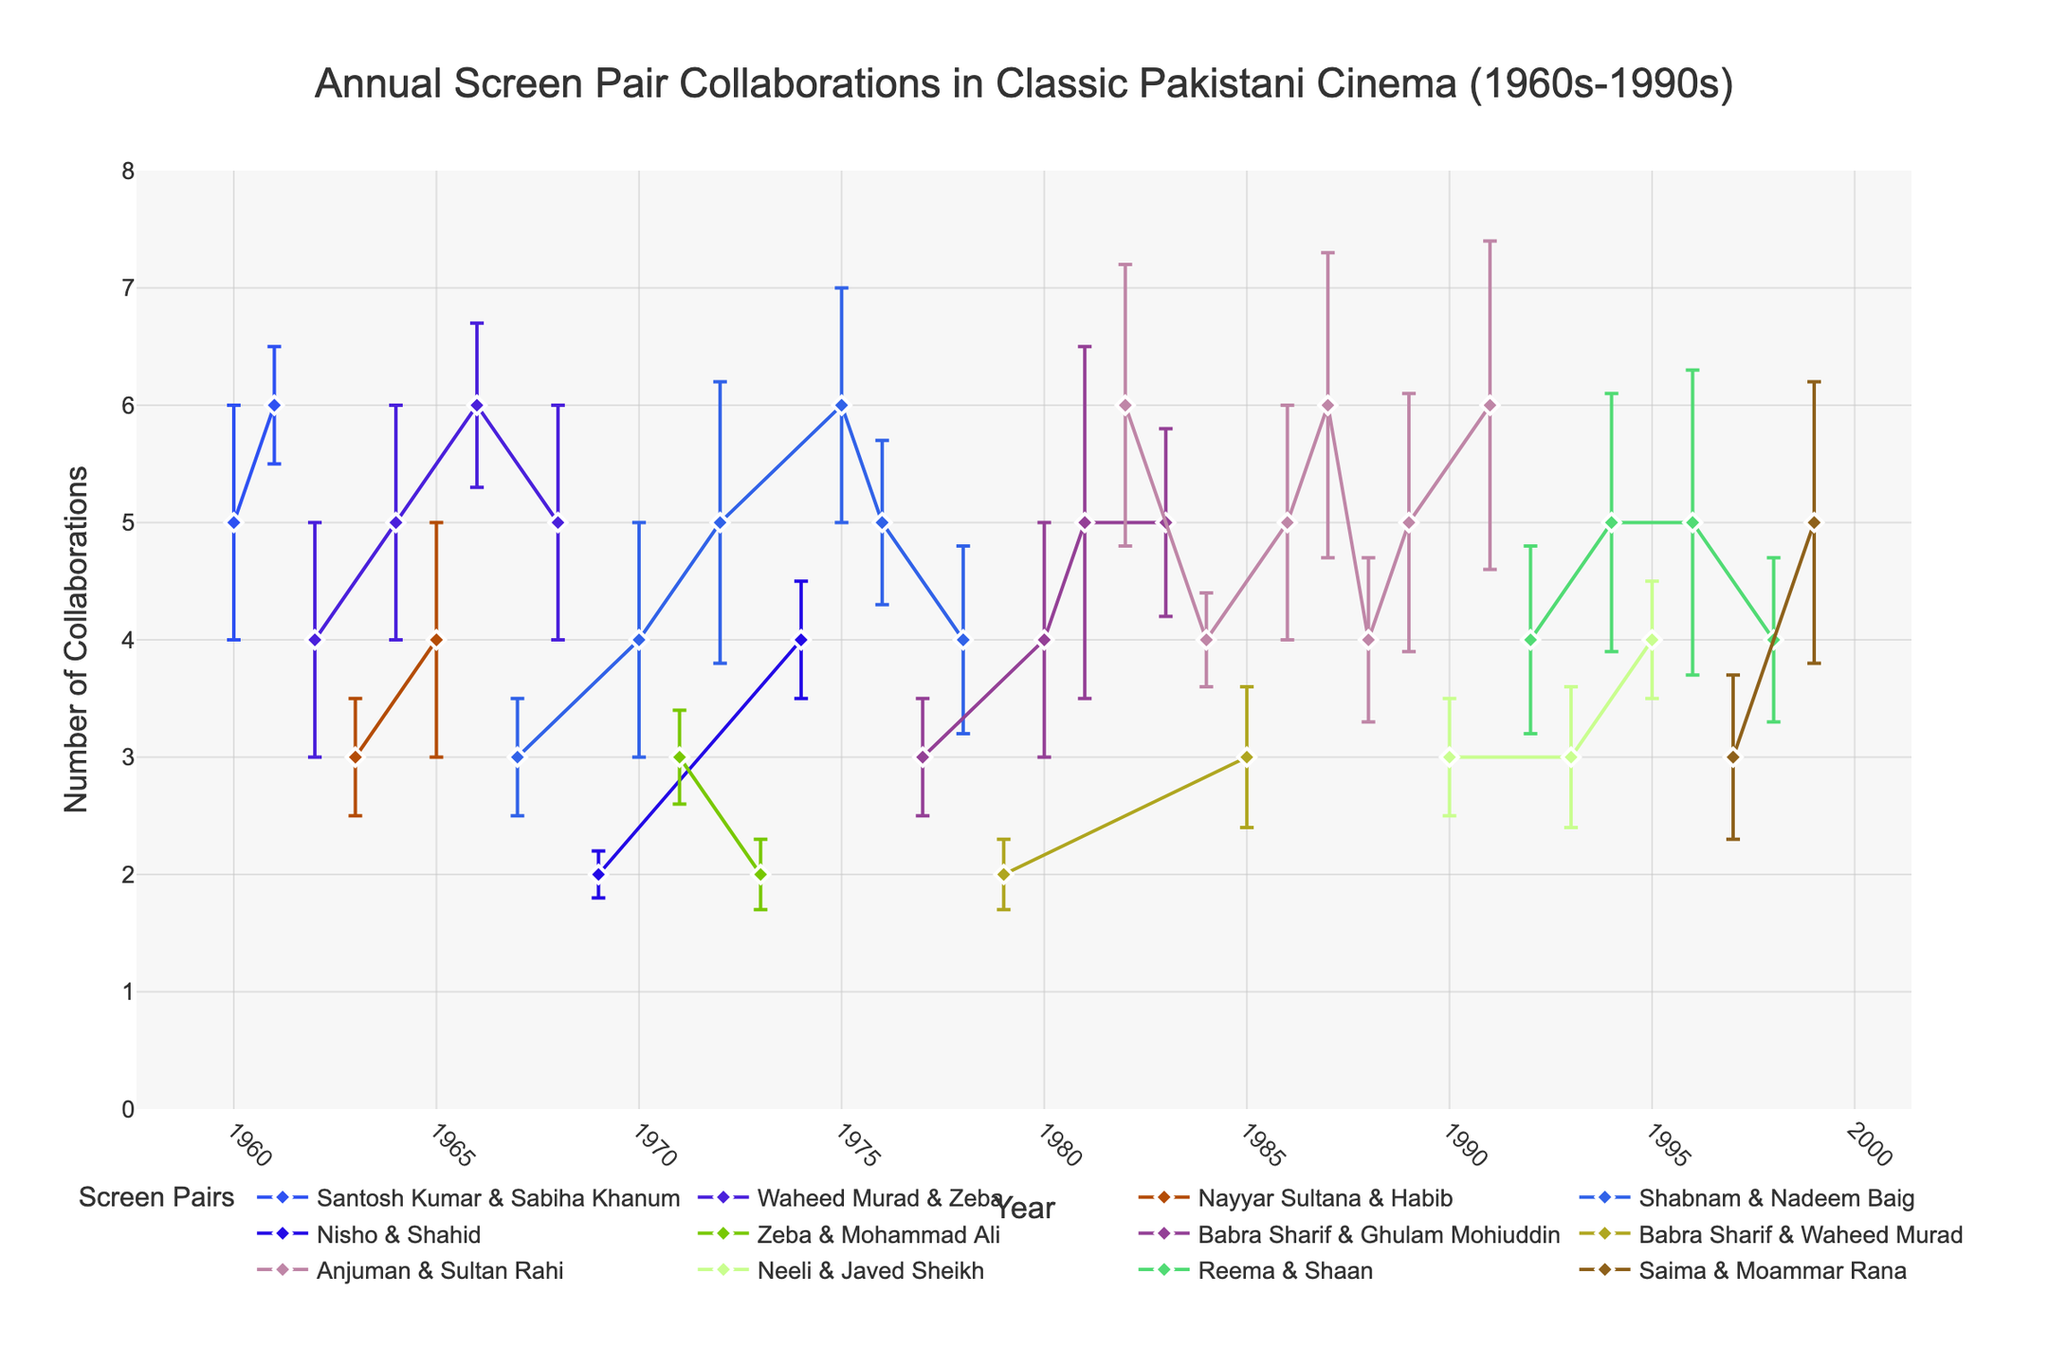How many collaborations did Shabnam & Nadeem Baig have in 1970? Look for the data point for Shabnam & Nadeem Baig in the year 1970. The y-axis value associated with that point is the number of collaborations.
Answer: 4 Which screen pair had the highest number of collaborations in 1982, and how many were there? Find the data points for the year 1982 and identify the screen pair with the highest y-axis value.
Answer: Anjuman & Sultan Rahi, 6 What is the average number of collaborations for Waheed Murad & Zeba between 1962 and 1968? List the number of collaborations for Waheed Murad & Zeba in the years 1962, 1964, 1966, and 1968. Then, sum those values and divide by the number of data points.
Answer: 5 In which year did Babra Sharif & Ghulam Mohiuddin have the least number of collaborations, and what was the number? Look at the data points for Babra Sharif & Ghulam Mohiuddin and find the year with the smallest y-axis value.
Answer: 1977, 3 How many total collaborations did Anjuman & Sultan Rahi have from 1982 to 1989? Sum the number of collaborations for Anjuman & Sultan Rahi for the years 1982, 1984, 1986, 1987, and 1989.
Answer: 26 Which screen pair showed the largest error bar in their collaborative frequency, and in which year did it occur? Identify the longest error bar (y-axis deviation) and note the screen pair and year associated with that bar.
Answer: Babra Sharif & Ghulam Mohiuddin, 1981 What is the trend in collaborations for Reema & Shaan from 1992 to 1998? Observe the data points for Reema & Shaan for the years 1992, 1994, 1996, and 1998. Describe whether the number of collaborations is increasing, decreasing, or stable over these years.
Answer: Alternating Which pair had more collaborations in their peak collaboration year: Shabnam & Nadeem Baig or Anjuman & Sultan Rahi? Compare the highest number of collaborations for Shabnam & Nadeem Baig and Anjuman & Sultan Rahi across all years.
Answer: Anjuman & Sultan Rahi What was the deviation in collaborations for Santosh Kumar & Sabiha Khanum in 1960? Identify the error bar for the data point of Santosh Kumar & Sabiha Khanum in 1960.
Answer: 1 